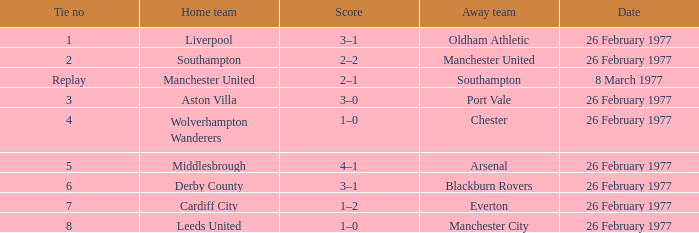What's the score when the tie number was 6? 3–1. 